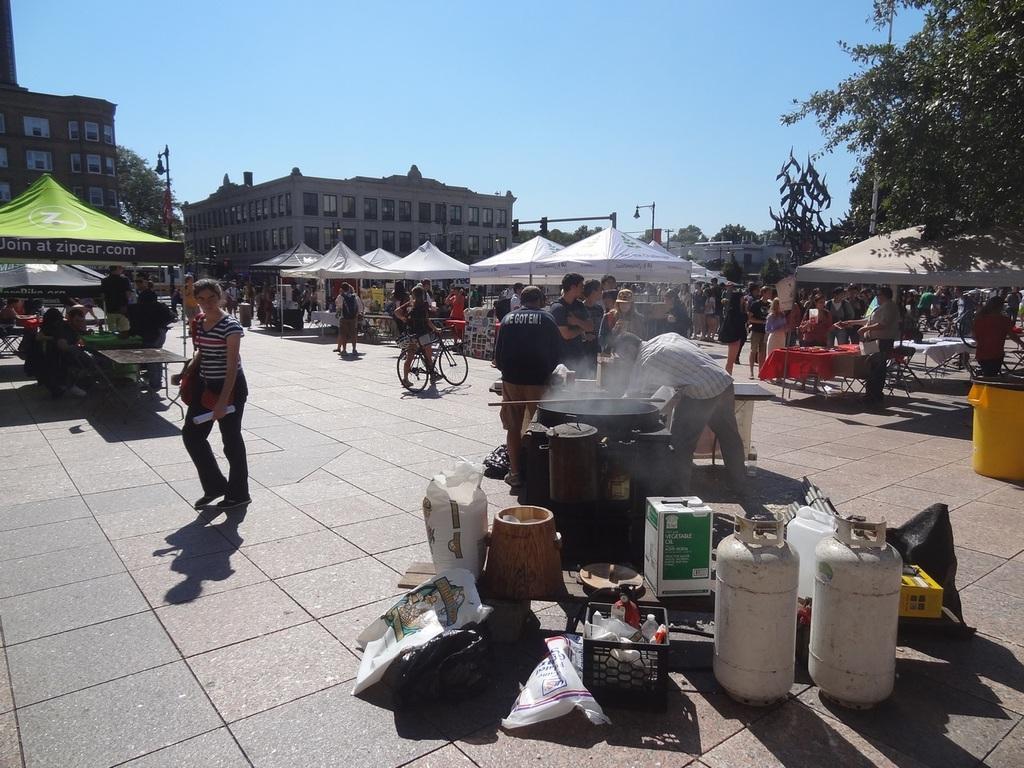Describe this image in one or two sentences. In the foreground of the image there are objects. There are stalls. In the background of the image there are buildings, trees, sky. There are people. At the bottom of the image there is floor. 